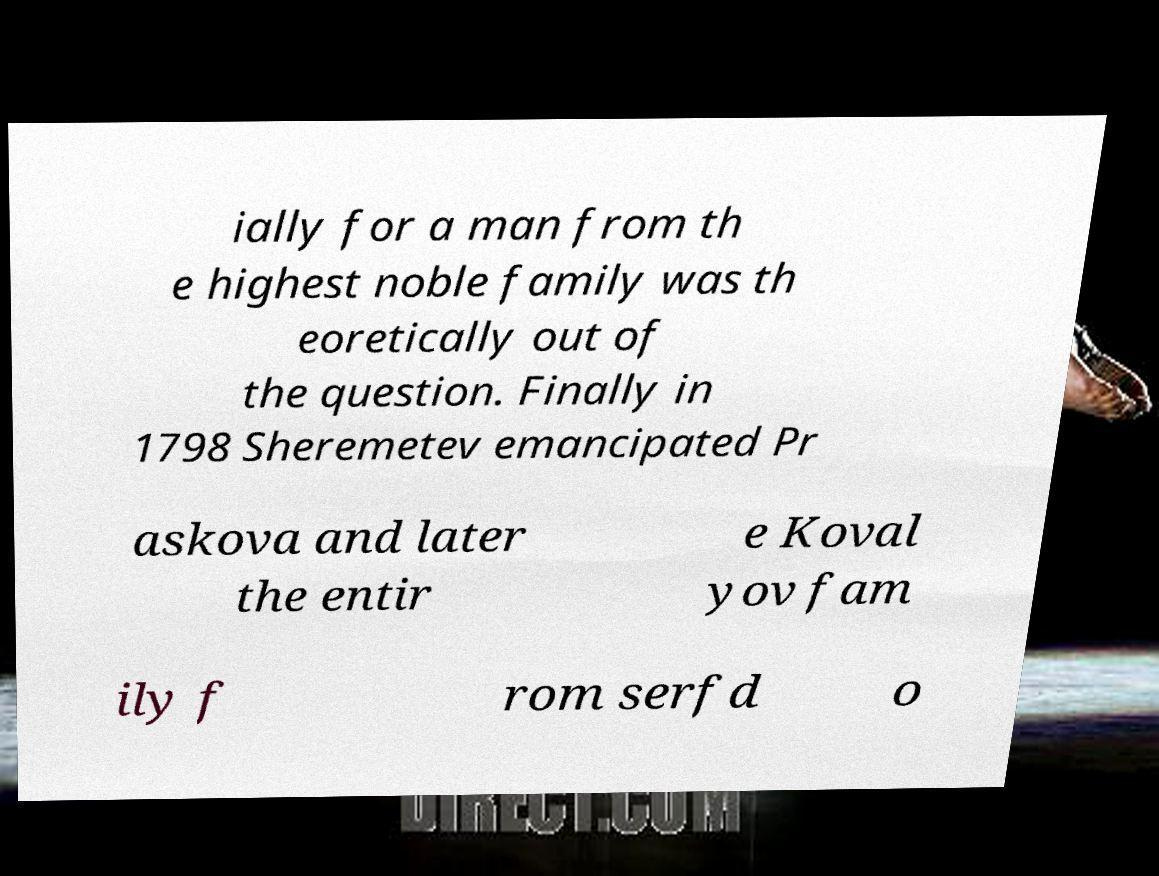I need the written content from this picture converted into text. Can you do that? ially for a man from th e highest noble family was th eoretically out of the question. Finally in 1798 Sheremetev emancipated Pr askova and later the entir e Koval yov fam ily f rom serfd o 